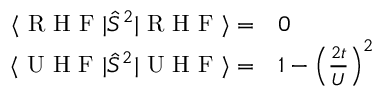Convert formula to latex. <formula><loc_0><loc_0><loc_500><loc_500>\begin{array} { r l } { \langle R H F | \hat { S } ^ { 2 } | R H F \rangle = } & 0 } \\ { \langle U H F | \hat { S } ^ { 2 } | U H F \rangle = } & 1 - \left ( \frac { 2 t } { U } \right ) ^ { 2 } } \end{array}</formula> 